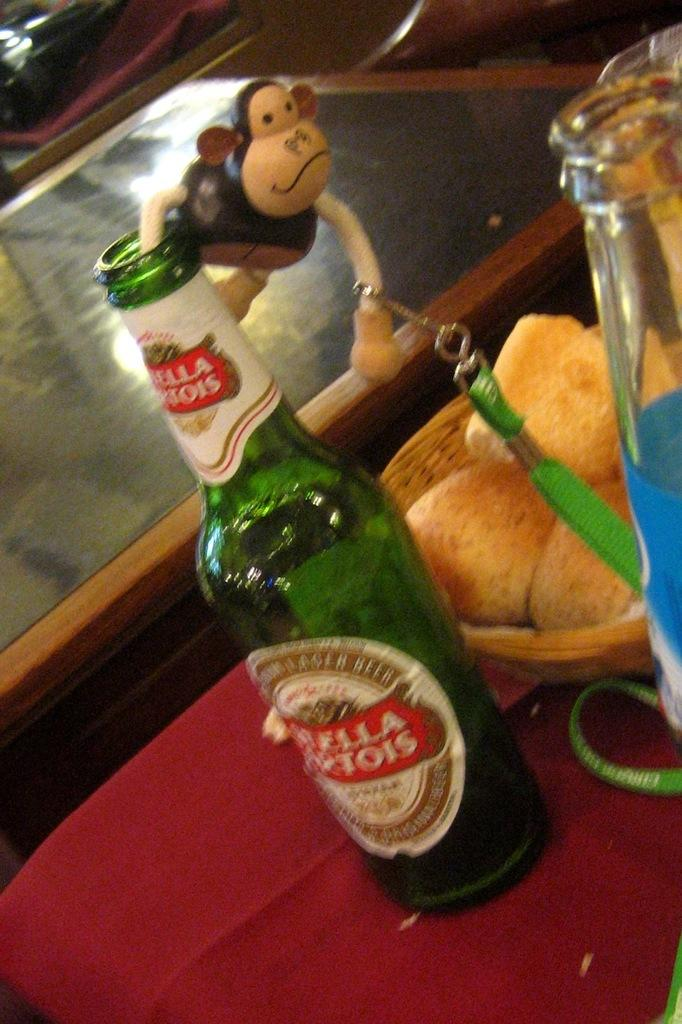What objects are on the table in the image? There are bottles and food on the table in the image. What else can be seen on the table? There is an identity card on the table. What color is the cloth covering the table? The table is covered with a red cloth. How many buttons are on the corn in the image? There is no corn or buttons present in the image. What type of feet can be seen walking in the image? There are no feet visible in the image. 